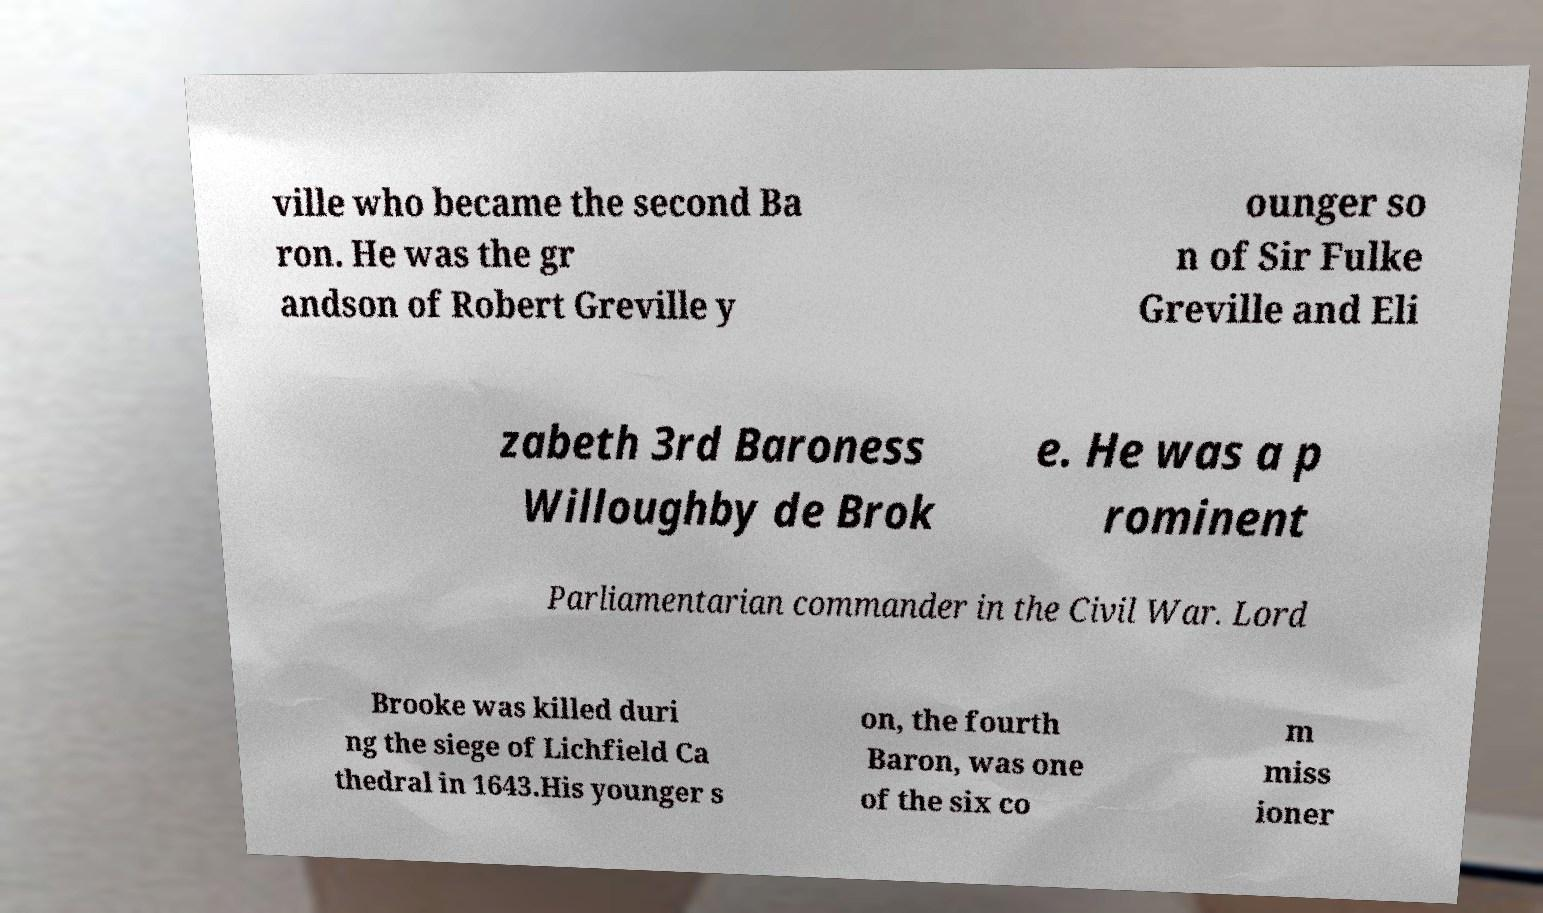Please read and relay the text visible in this image. What does it say? ville who became the second Ba ron. He was the gr andson of Robert Greville y ounger so n of Sir Fulke Greville and Eli zabeth 3rd Baroness Willoughby de Brok e. He was a p rominent Parliamentarian commander in the Civil War. Lord Brooke was killed duri ng the siege of Lichfield Ca thedral in 1643.His younger s on, the fourth Baron, was one of the six co m miss ioner 